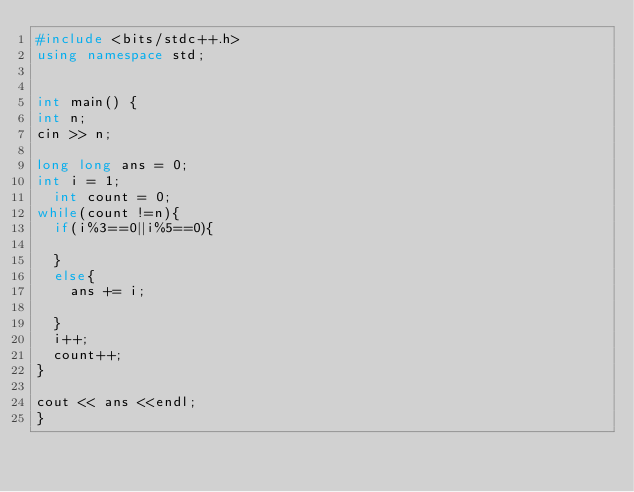<code> <loc_0><loc_0><loc_500><loc_500><_C++_>#include <bits/stdc++.h>
using namespace std;


int main() {
int n;
cin >> n;

long long ans = 0;
int i = 1;
  int count = 0;
while(count !=n){
	if(i%3==0||i%5==0){
		
	}
  else{
    ans += i;
		
  }
	i++;
  count++;
}

cout << ans <<endl;
}</code> 